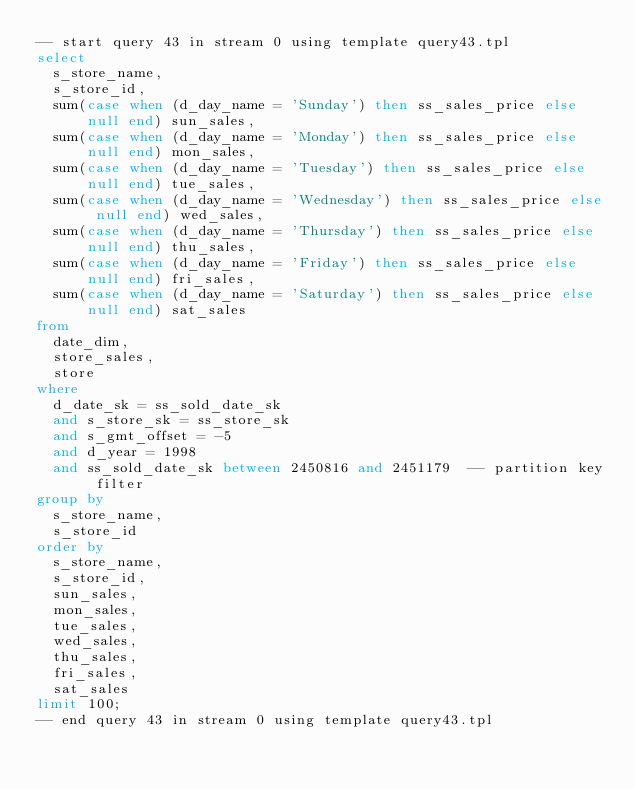Convert code to text. <code><loc_0><loc_0><loc_500><loc_500><_SQL_>-- start query 43 in stream 0 using template query43.tpl
select
  s_store_name,
  s_store_id,
  sum(case when (d_day_name = 'Sunday') then ss_sales_price else null end) sun_sales,
  sum(case when (d_day_name = 'Monday') then ss_sales_price else null end) mon_sales,
  sum(case when (d_day_name = 'Tuesday') then ss_sales_price else null end) tue_sales,
  sum(case when (d_day_name = 'Wednesday') then ss_sales_price else null end) wed_sales,
  sum(case when (d_day_name = 'Thursday') then ss_sales_price else null end) thu_sales,
  sum(case when (d_day_name = 'Friday') then ss_sales_price else null end) fri_sales,
  sum(case when (d_day_name = 'Saturday') then ss_sales_price else null end) sat_sales
from
  date_dim,
  store_sales,
  store
where
  d_date_sk = ss_sold_date_sk
  and s_store_sk = ss_store_sk
  and s_gmt_offset = -5
  and d_year = 1998
  and ss_sold_date_sk between 2450816 and 2451179  -- partition key filter
group by
  s_store_name,
  s_store_id
order by
  s_store_name,
  s_store_id,
  sun_sales,
  mon_sales,
  tue_sales,
  wed_sales,
  thu_sales,
  fri_sales,
  sat_sales
limit 100;
-- end query 43 in stream 0 using template query43.tpl
</code> 